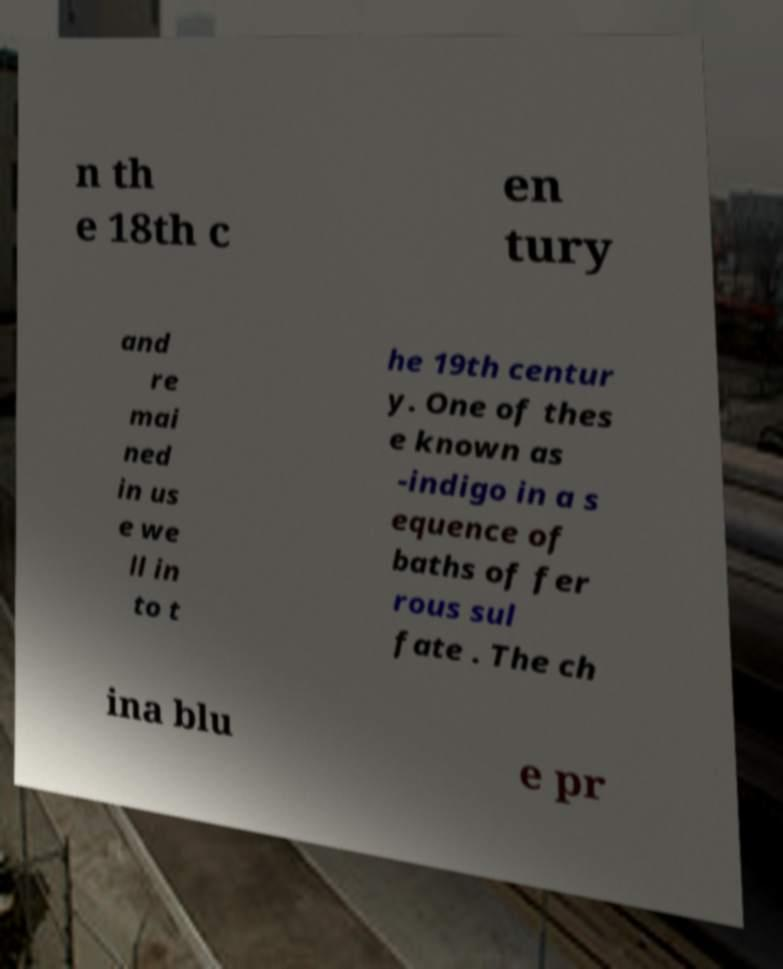Could you assist in decoding the text presented in this image and type it out clearly? n th e 18th c en tury and re mai ned in us e we ll in to t he 19th centur y. One of thes e known as -indigo in a s equence of baths of fer rous sul fate . The ch ina blu e pr 